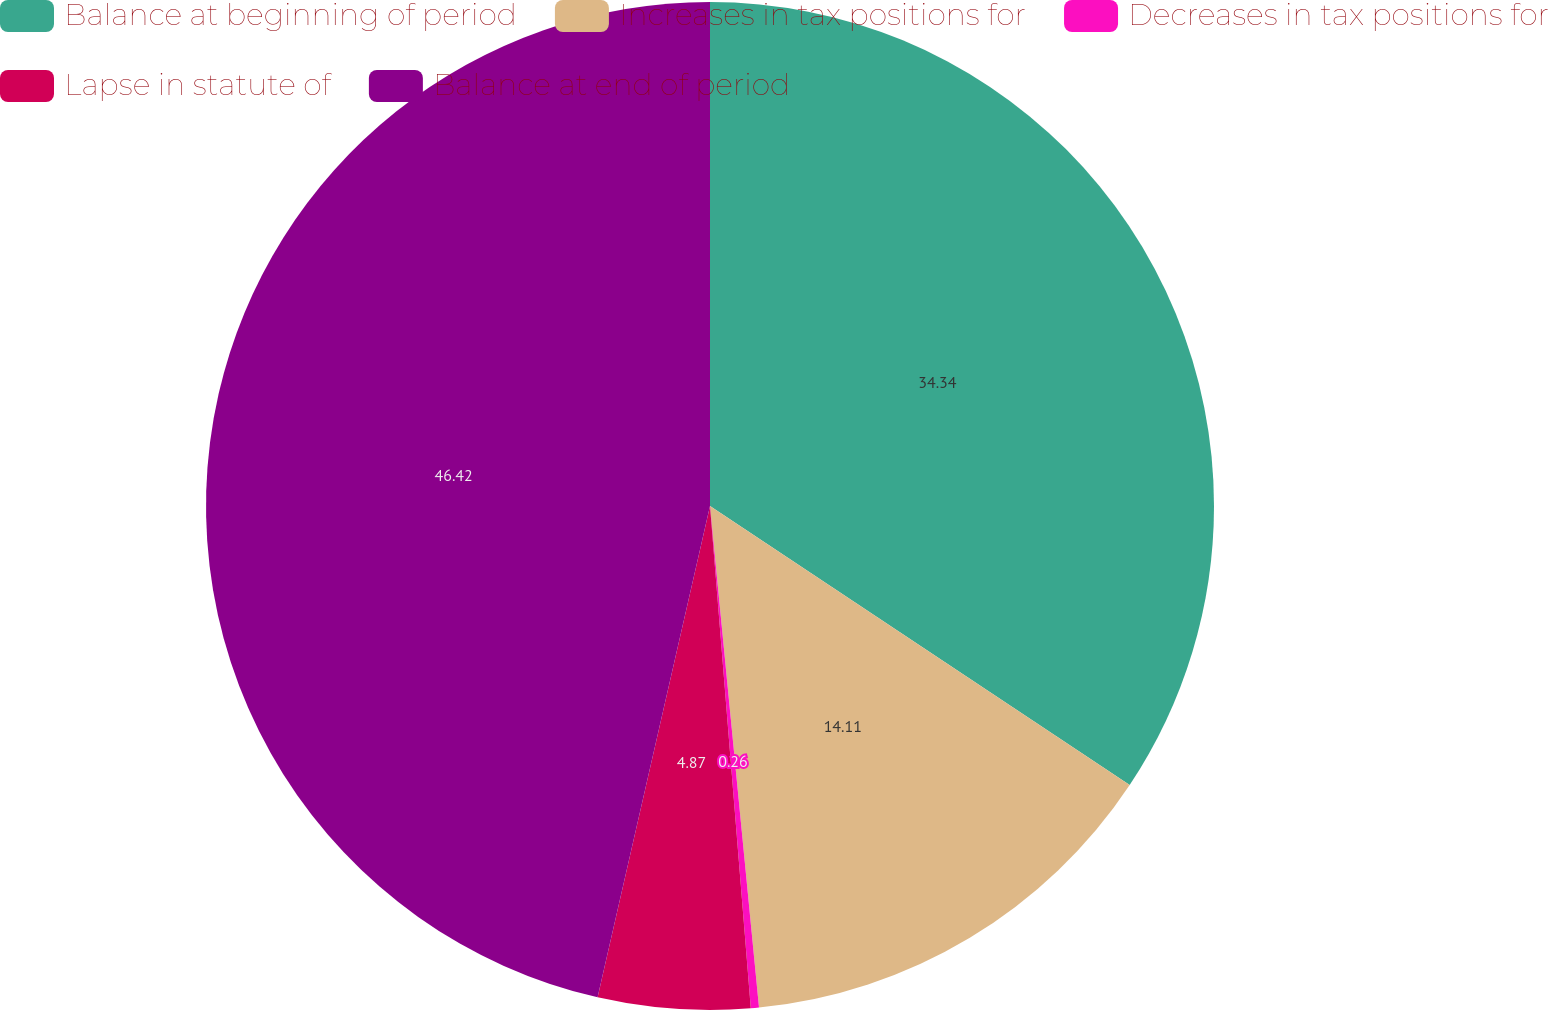Convert chart to OTSL. <chart><loc_0><loc_0><loc_500><loc_500><pie_chart><fcel>Balance at beginning of period<fcel>Increases in tax positions for<fcel>Decreases in tax positions for<fcel>Lapse in statute of<fcel>Balance at end of period<nl><fcel>34.34%<fcel>14.11%<fcel>0.26%<fcel>4.87%<fcel>46.42%<nl></chart> 